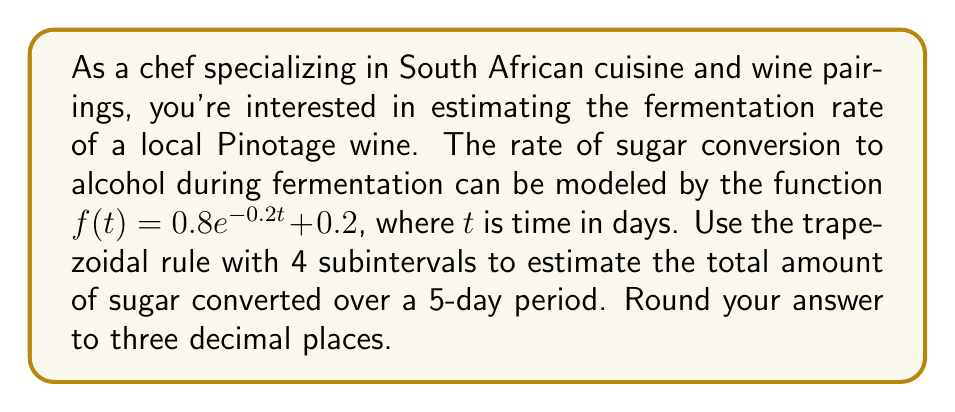Can you answer this question? To solve this problem, we'll use the trapezoidal rule for numerical integration:

1) The trapezoidal rule formula for n subintervals is:

   $$\int_{a}^{b} f(x) dx \approx \frac{h}{2}[f(x_0) + 2f(x_1) + 2f(x_2) + ... + 2f(x_{n-1}) + f(x_n)]$$

   where $h = \frac{b-a}{n}$, and $x_i = a + ih$ for $i = 0, 1, ..., n$

2) In our case:
   $a = 0$, $b = 5$, $n = 4$, so $h = \frac{5-0}{4} = 1.25$

3) Calculate the function values:
   $f(0) = 0.8e^{-0.2(0)} + 0.2 = 1$
   $f(1.25) = 0.8e^{-0.2(1.25)} + 0.2 \approx 0.8$
   $f(2.5) = 0.8e^{-0.2(2.5)} + 0.2 \approx 0.672$
   $f(3.75) = 0.8e^{-0.2(3.75)} + 0.2 \approx 0.587$
   $f(5) = 0.8e^{-0.2(5)} + 0.2 \approx 0.530$

4) Apply the trapezoidal rule:
   $$\int_{0}^{5} f(t) dt \approx \frac{1.25}{2}[1 + 2(0.8) + 2(0.672) + 2(0.587) + 0.530]$$
   $$= 0.625[1 + 1.6 + 1.344 + 1.174 + 0.530]$$
   $$= 0.625(5.648) = 3.53$$

5) Round to three decimal places: 3.530

This result represents the estimated total amount of sugar converted over the 5-day period.
Answer: 3.530 